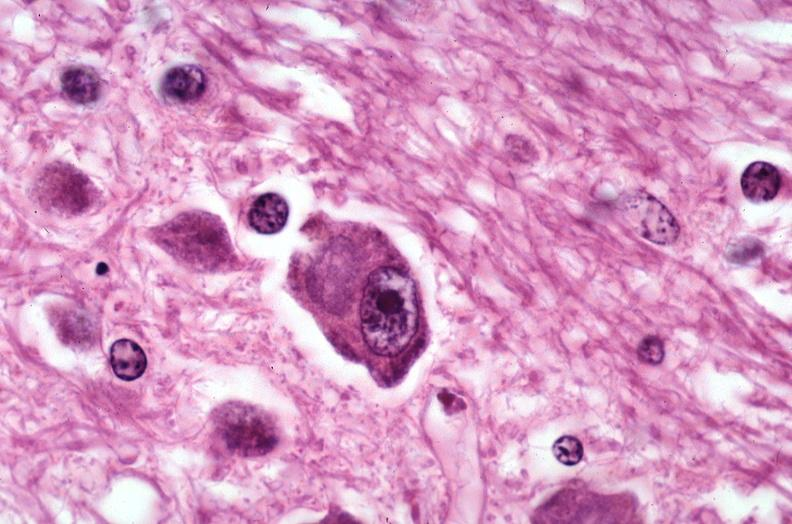s pus in test tube present?
Answer the question using a single word or phrase. No 